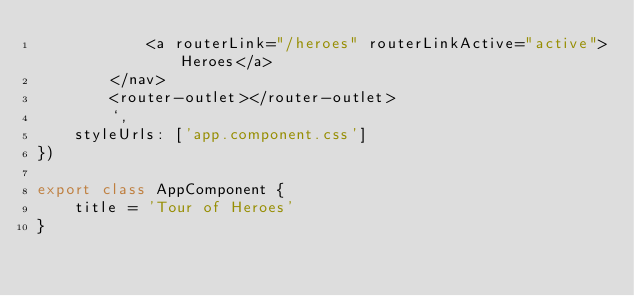<code> <loc_0><loc_0><loc_500><loc_500><_TypeScript_>            <a routerLink="/heroes" routerLinkActive="active">Heroes</a>
        </nav>
        <router-outlet></router-outlet>
        `,
    styleUrls: ['app.component.css']
})

export class AppComponent {
    title = 'Tour of Heroes'
}</code> 